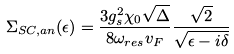Convert formula to latex. <formula><loc_0><loc_0><loc_500><loc_500>\Sigma _ { S C , a n } ( \epsilon ) = \frac { 3 g ^ { 2 } _ { s } \chi _ { 0 } \sqrt { \Delta } } { 8 \omega _ { r e s } v _ { F } } \frac { \sqrt { 2 } } { \sqrt { \epsilon - i \delta } }</formula> 